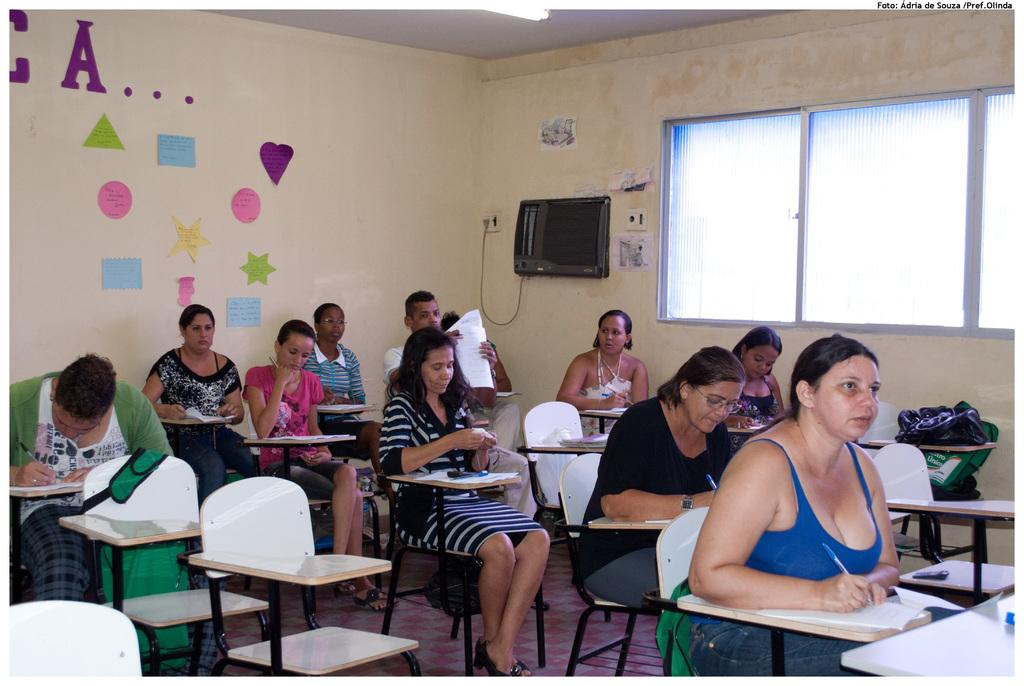How many people are in the image? There is a group of people in the image. What are the people doing in the image? The people are sitting in chairs and writing on paper with pens. What can be seen in the background of the image? There is a television, papers attached to the wall, a window, and a bag in the background of the image. What type of meal is being prepared in the image? There is no indication of a meal being prepared in the image; the people are writing on paper with pens. Can you see any wrens in the image? There are no wrens present in the image. 